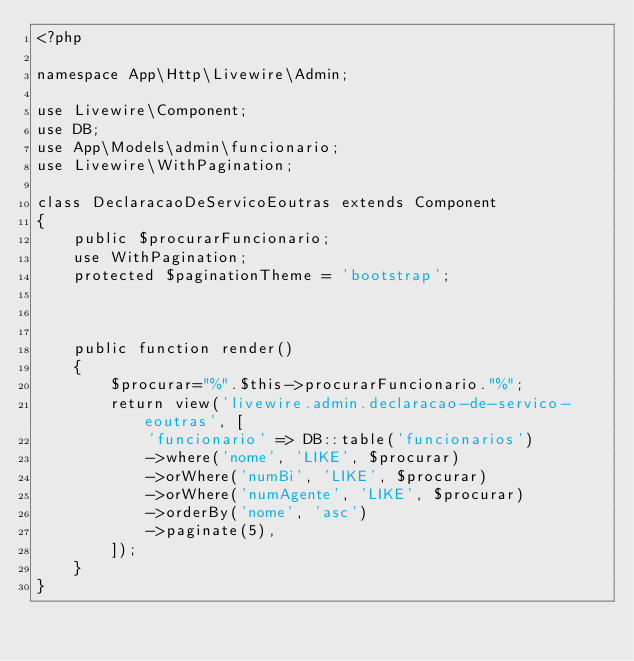Convert code to text. <code><loc_0><loc_0><loc_500><loc_500><_PHP_><?php

namespace App\Http\Livewire\Admin;

use Livewire\Component;
use DB;
use App\Models\admin\funcionario;
use Livewire\WithPagination;

class DeclaracaoDeServicoEoutras extends Component
{
    public $procurarFuncionario;
    use WithPagination;
    protected $paginationTheme = 'bootstrap';



    public function render()
    {
        $procurar="%".$this->procurarFuncionario."%";
        return view('livewire.admin.declaracao-de-servico-eoutras', [
            'funcionario' => DB::table('funcionarios')
            ->where('nome', 'LIKE', $procurar)
            ->orWhere('numBi', 'LIKE', $procurar)
            ->orWhere('numAgente', 'LIKE', $procurar)
            ->orderBy('nome', 'asc')
            ->paginate(5),
        ]);
    }
}
</code> 